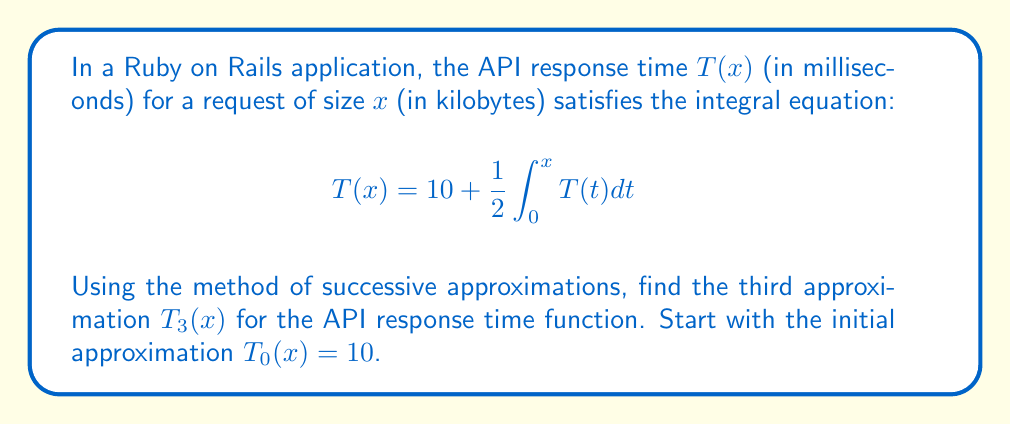Provide a solution to this math problem. Let's apply the method of successive approximations:

1) Initial approximation: $T_0(x) = 10$

2) First approximation:
   $$T_1(x) = 10 + \frac{1}{2}\int_0^x T_0(t) dt = 10 + \frac{1}{2}\int_0^x 10 dt = 10 + 5x$$

3) Second approximation:
   $$\begin{align*}
   T_2(x) &= 10 + \frac{1}{2}\int_0^x T_1(t) dt \\
   &= 10 + \frac{1}{2}\int_0^x (10 + 5t) dt \\
   &= 10 + \frac{1}{2}[10t + \frac{5t^2}{2}]_0^x \\
   &= 10 + 5x + \frac{5x^2}{4}
   \end{align*}$$

4) Third approximation:
   $$\begin{align*}
   T_3(x) &= 10 + \frac{1}{2}\int_0^x T_2(t) dt \\
   &= 10 + \frac{1}{2}\int_0^x (10 + 5t + \frac{5t^2}{4}) dt \\
   &= 10 + \frac{1}{2}[10t + \frac{5t^2}{2} + \frac{5t^3}{12}]_0^x \\
   &= 10 + 5x + \frac{5x^2}{4} + \frac{5x^3}{24}
   \end{align*}$$

Thus, the third approximation $T_3(x)$ is obtained.
Answer: $T_3(x) = 10 + 5x + \frac{5x^2}{4} + \frac{5x^3}{24}$ 